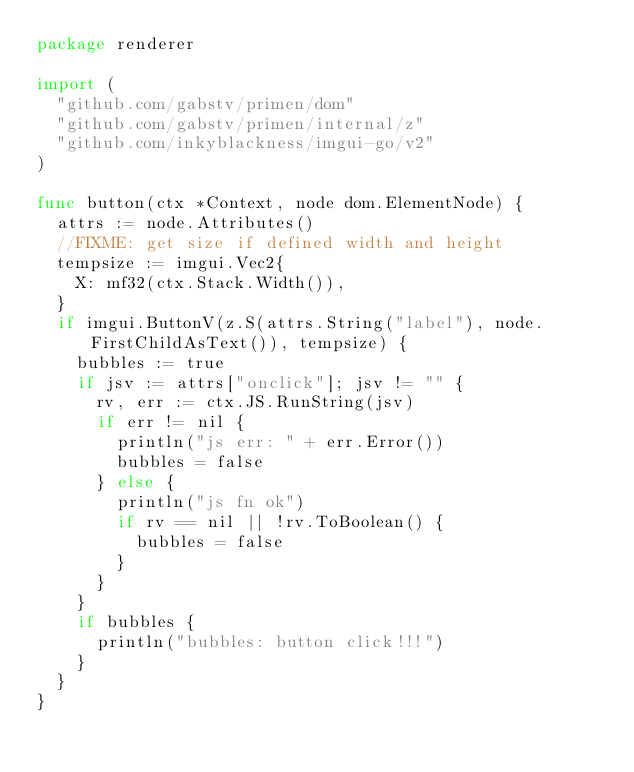<code> <loc_0><loc_0><loc_500><loc_500><_Go_>package renderer

import (
	"github.com/gabstv/primen/dom"
	"github.com/gabstv/primen/internal/z"
	"github.com/inkyblackness/imgui-go/v2"
)

func button(ctx *Context, node dom.ElementNode) {
	attrs := node.Attributes()
	//FIXME: get size if defined width and height
	tempsize := imgui.Vec2{
		X: mf32(ctx.Stack.Width()),
	}
	if imgui.ButtonV(z.S(attrs.String("label"), node.FirstChildAsText()), tempsize) {
		bubbles := true
		if jsv := attrs["onclick"]; jsv != "" {
			rv, err := ctx.JS.RunString(jsv)
			if err != nil {
				println("js err: " + err.Error())
				bubbles = false
			} else {
				println("js fn ok")
				if rv == nil || !rv.ToBoolean() {
					bubbles = false
				}
			}
		}
		if bubbles {
			println("bubbles: button click!!!")
		}
	}
}
</code> 